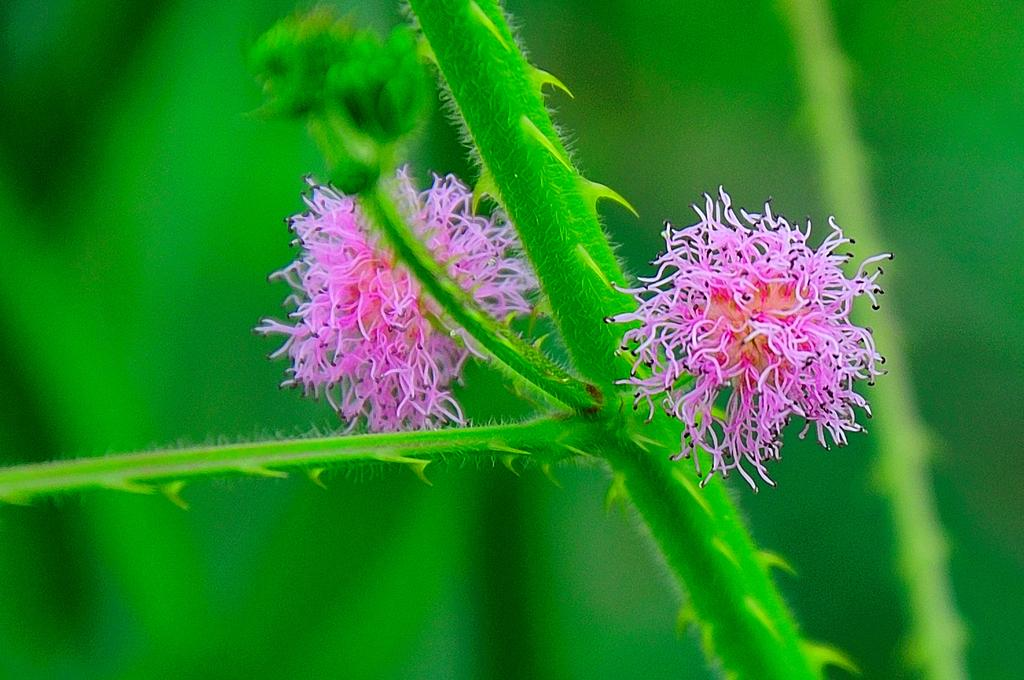What is the main subject of the image? There is a plant in the image. What specific feature of the plant can be observed? The plant has flowers. How would you describe the background of the image? The background of the image is blurred and green in color. What type of story is being told by the heat in the image? There is no heat present in the image, and therefore no story can be told by it. 